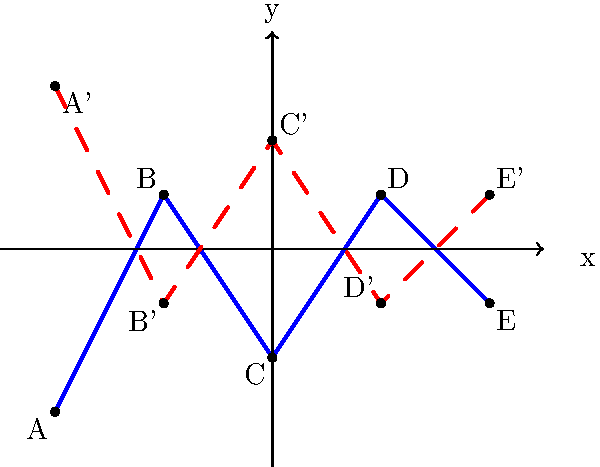In a dystopian novel, the author describes a cityscape represented by the blue line in the graph. If this cityscape is reflected across the x-axis to create a mirrored underground world, what are the coordinates of point C' (the reflection of point C) in the reflected cityscape? To find the coordinates of point C' after reflecting the cityscape across the x-axis, we need to follow these steps:

1. Identify the original coordinates of point C:
   From the graph, we can see that C is located at (0, -2).

2. Understand the reflection across the x-axis:
   When reflecting a point across the x-axis, the x-coordinate remains the same, while the y-coordinate changes sign.

3. Apply the reflection to point C:
   - The x-coordinate of C' will be the same as C: 0
   - The y-coordinate of C' will be the opposite of C's y-coordinate: -(-2) = 2

4. Combine the new coordinates:
   C' will be located at (0, 2)

This reflection creates a mirrored underground world, symbolizing the duality often found in dystopian novels – a theme that could revolutionize the young adult dystopian genre.
Answer: (0, 2) 